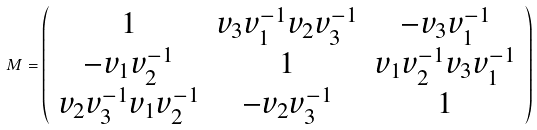<formula> <loc_0><loc_0><loc_500><loc_500>M = \left ( \begin{array} { c c c } 1 & v _ { 3 } v _ { 1 } ^ { - 1 } v _ { 2 } v _ { 3 } ^ { - 1 } & - v _ { 3 } v _ { 1 } ^ { - 1 } \\ - v _ { 1 } v _ { 2 } ^ { - 1 } & 1 & v _ { 1 } v _ { 2 } ^ { - 1 } v _ { 3 } v _ { 1 } ^ { - 1 } \\ v _ { 2 } v _ { 3 } ^ { - 1 } v _ { 1 } v _ { 2 } ^ { - 1 } & - v _ { 2 } v _ { 3 } ^ { - 1 } & 1 \\ \end{array} \right )</formula> 